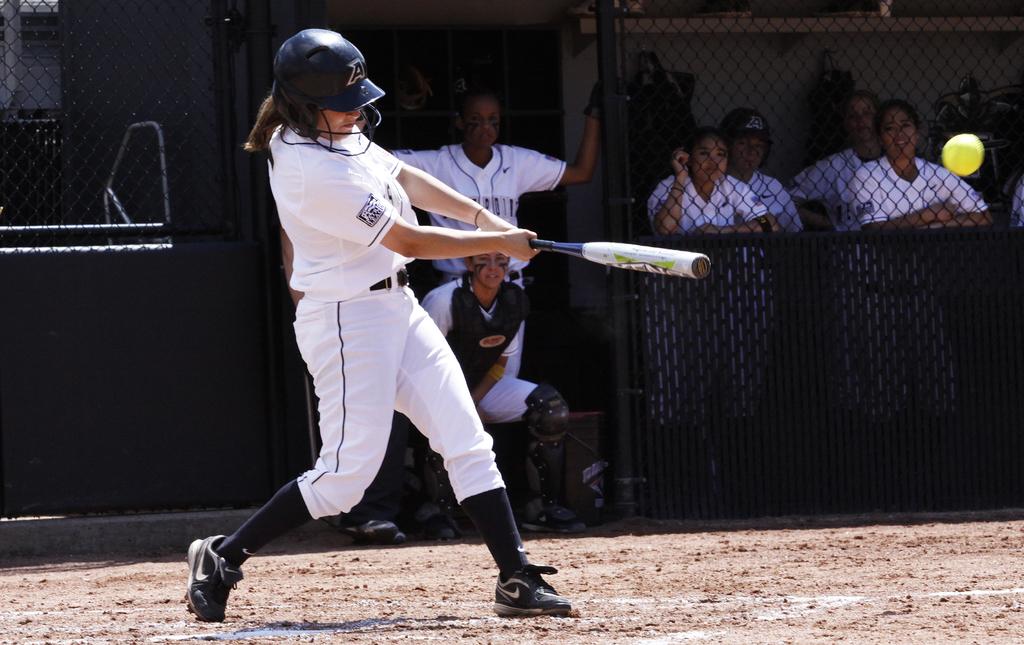What letter is on the batting helmet?
Provide a short and direct response. A. 